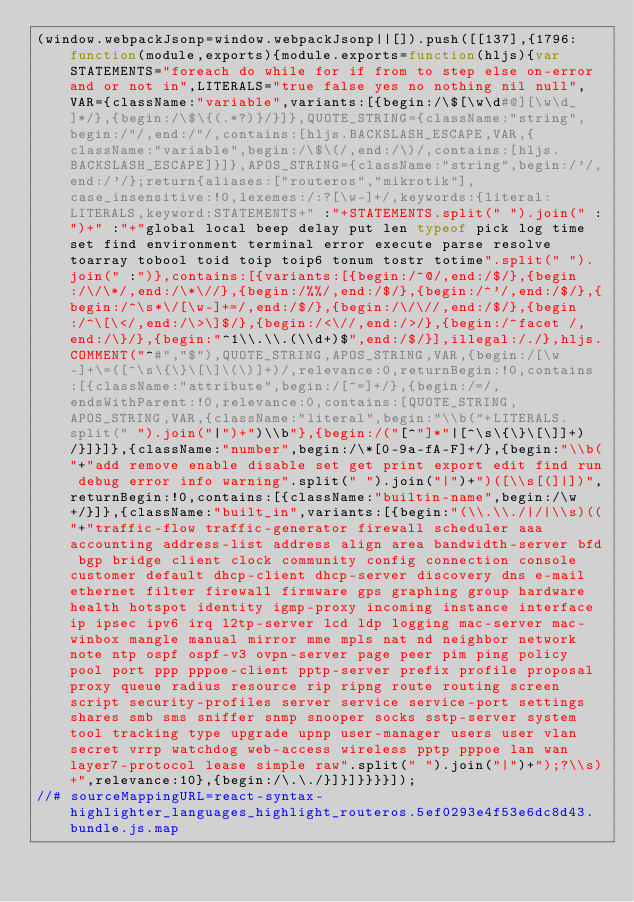<code> <loc_0><loc_0><loc_500><loc_500><_JavaScript_>(window.webpackJsonp=window.webpackJsonp||[]).push([[137],{1796:function(module,exports){module.exports=function(hljs){var STATEMENTS="foreach do while for if from to step else on-error and or not in",LITERALS="true false yes no nothing nil null",VAR={className:"variable",variants:[{begin:/\$[\w\d#@][\w\d_]*/},{begin:/\$\{(.*?)}/}]},QUOTE_STRING={className:"string",begin:/"/,end:/"/,contains:[hljs.BACKSLASH_ESCAPE,VAR,{className:"variable",begin:/\$\(/,end:/\)/,contains:[hljs.BACKSLASH_ESCAPE]}]},APOS_STRING={className:"string",begin:/'/,end:/'/};return{aliases:["routeros","mikrotik"],case_insensitive:!0,lexemes:/:?[\w-]+/,keywords:{literal:LITERALS,keyword:STATEMENTS+" :"+STATEMENTS.split(" ").join(" :")+" :"+"global local beep delay put len typeof pick log time set find environment terminal error execute parse resolve toarray tobool toid toip toip6 tonum tostr totime".split(" ").join(" :")},contains:[{variants:[{begin:/^@/,end:/$/},{begin:/\/\*/,end:/\*\//},{begin:/%%/,end:/$/},{begin:/^'/,end:/$/},{begin:/^\s*\/[\w-]+=/,end:/$/},{begin:/\/\//,end:/$/},{begin:/^\[\</,end:/\>\]$/},{begin:/<\//,end:/>/},{begin:/^facet /,end:/\}/},{begin:"^1\\.\\.(\\d+)$",end:/$/}],illegal:/./},hljs.COMMENT("^#","$"),QUOTE_STRING,APOS_STRING,VAR,{begin:/[\w-]+\=([^\s\{\}\[\]\(\)]+)/,relevance:0,returnBegin:!0,contains:[{className:"attribute",begin:/[^=]+/},{begin:/=/,endsWithParent:!0,relevance:0,contains:[QUOTE_STRING,APOS_STRING,VAR,{className:"literal",begin:"\\b("+LITERALS.split(" ").join("|")+")\\b"},{begin:/("[^"]*"|[^\s\{\}\[\]]+)/}]}]},{className:"number",begin:/\*[0-9a-fA-F]+/},{begin:"\\b("+"add remove enable disable set get print export edit find run debug error info warning".split(" ").join("|")+")([\\s[(]|])",returnBegin:!0,contains:[{className:"builtin-name",begin:/\w+/}]},{className:"built_in",variants:[{begin:"(\\.\\./|/|\\s)(("+"traffic-flow traffic-generator firewall scheduler aaa accounting address-list address align area bandwidth-server bfd bgp bridge client clock community config connection console customer default dhcp-client dhcp-server discovery dns e-mail ethernet filter firewall firmware gps graphing group hardware health hotspot identity igmp-proxy incoming instance interface ip ipsec ipv6 irq l2tp-server lcd ldp logging mac-server mac-winbox mangle manual mirror mme mpls nat nd neighbor network note ntp ospf ospf-v3 ovpn-server page peer pim ping policy pool port ppp pppoe-client pptp-server prefix profile proposal proxy queue radius resource rip ripng route routing screen script security-profiles server service service-port settings shares smb sms sniffer snmp snooper socks sstp-server system tool tracking type upgrade upnp user-manager users user vlan secret vrrp watchdog web-access wireless pptp pppoe lan wan layer7-protocol lease simple raw".split(" ").join("|")+");?\\s)+",relevance:10},{begin:/\.\./}]}]}}}}]);
//# sourceMappingURL=react-syntax-highlighter_languages_highlight_routeros.5ef0293e4f53e6dc8d43.bundle.js.map</code> 